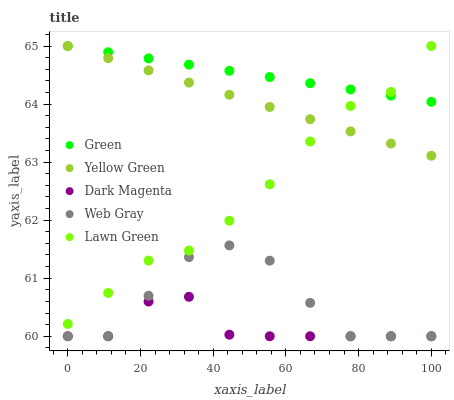Does Dark Magenta have the minimum area under the curve?
Answer yes or no. Yes. Does Green have the maximum area under the curve?
Answer yes or no. Yes. Does Web Gray have the minimum area under the curve?
Answer yes or no. No. Does Web Gray have the maximum area under the curve?
Answer yes or no. No. Is Green the smoothest?
Answer yes or no. Yes. Is Web Gray the roughest?
Answer yes or no. Yes. Is Web Gray the smoothest?
Answer yes or no. No. Is Green the roughest?
Answer yes or no. No. Does Web Gray have the lowest value?
Answer yes or no. Yes. Does Green have the lowest value?
Answer yes or no. No. Does Yellow Green have the highest value?
Answer yes or no. Yes. Does Web Gray have the highest value?
Answer yes or no. No. Is Dark Magenta less than Green?
Answer yes or no. Yes. Is Green greater than Web Gray?
Answer yes or no. Yes. Does Lawn Green intersect Yellow Green?
Answer yes or no. Yes. Is Lawn Green less than Yellow Green?
Answer yes or no. No. Is Lawn Green greater than Yellow Green?
Answer yes or no. No. Does Dark Magenta intersect Green?
Answer yes or no. No. 